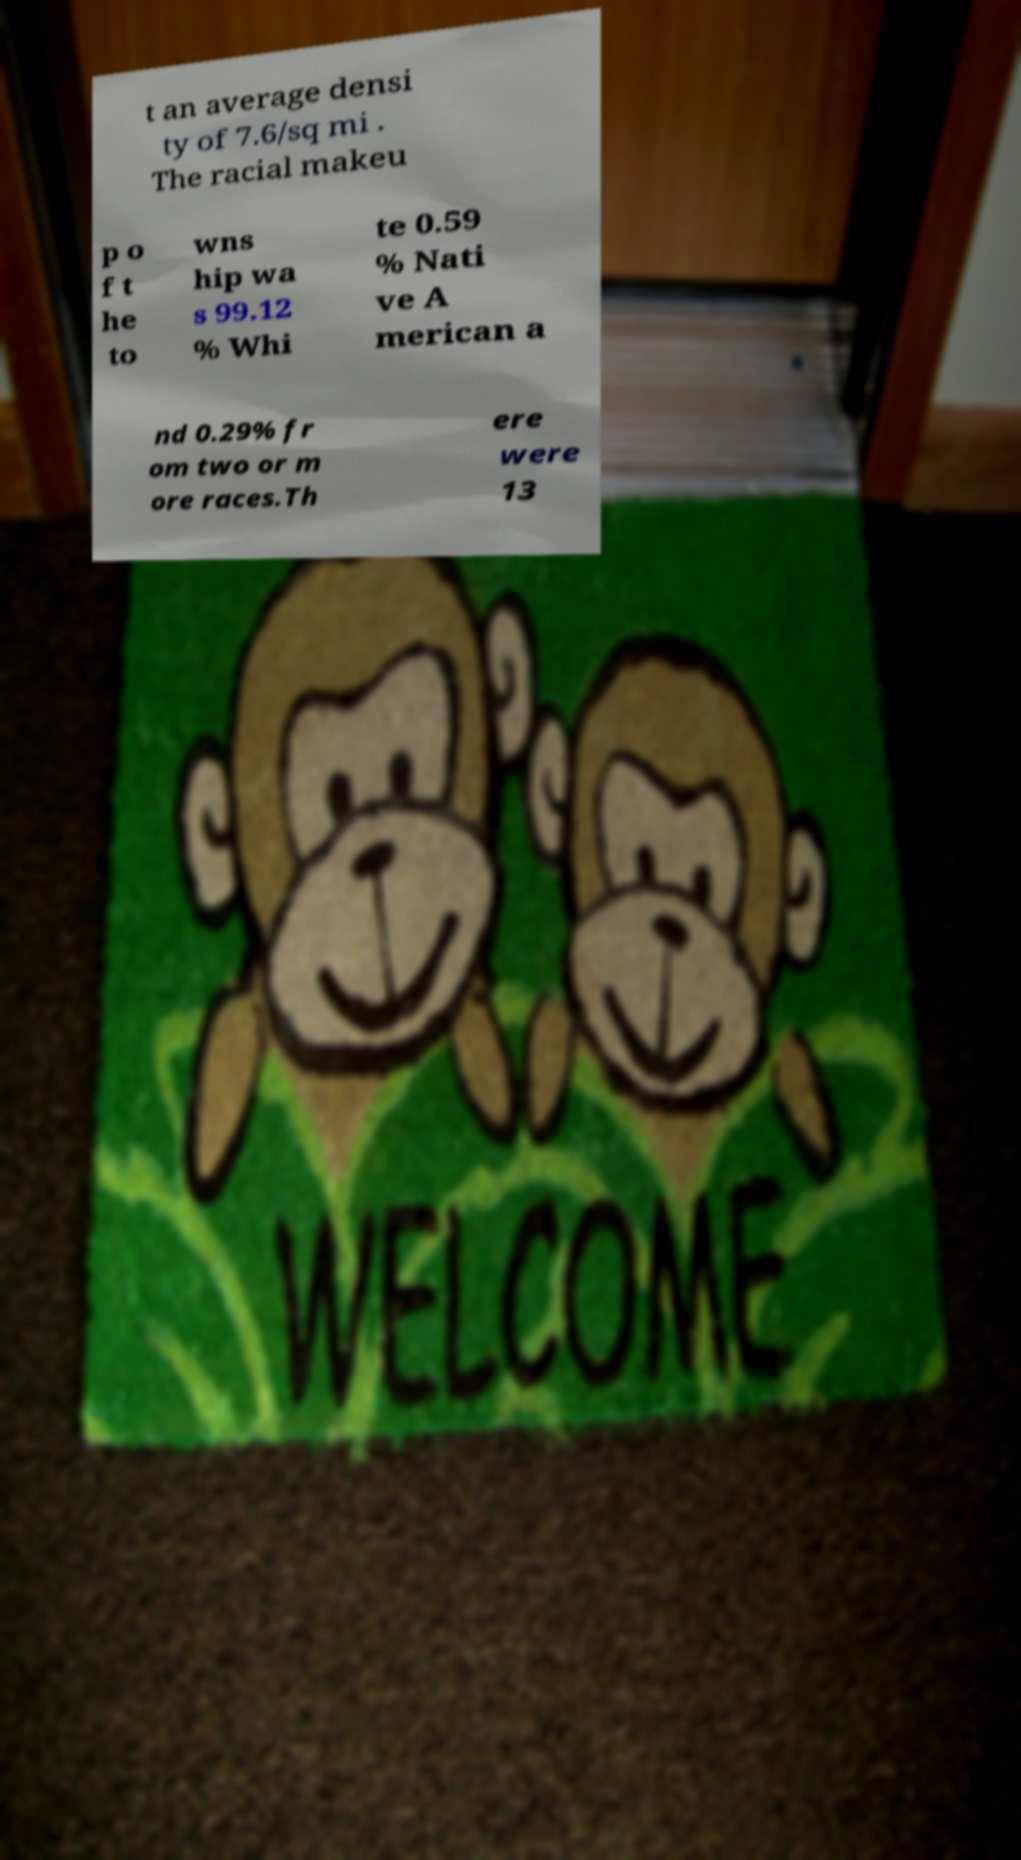Could you extract and type out the text from this image? t an average densi ty of 7.6/sq mi . The racial makeu p o f t he to wns hip wa s 99.12 % Whi te 0.59 % Nati ve A merican a nd 0.29% fr om two or m ore races.Th ere were 13 